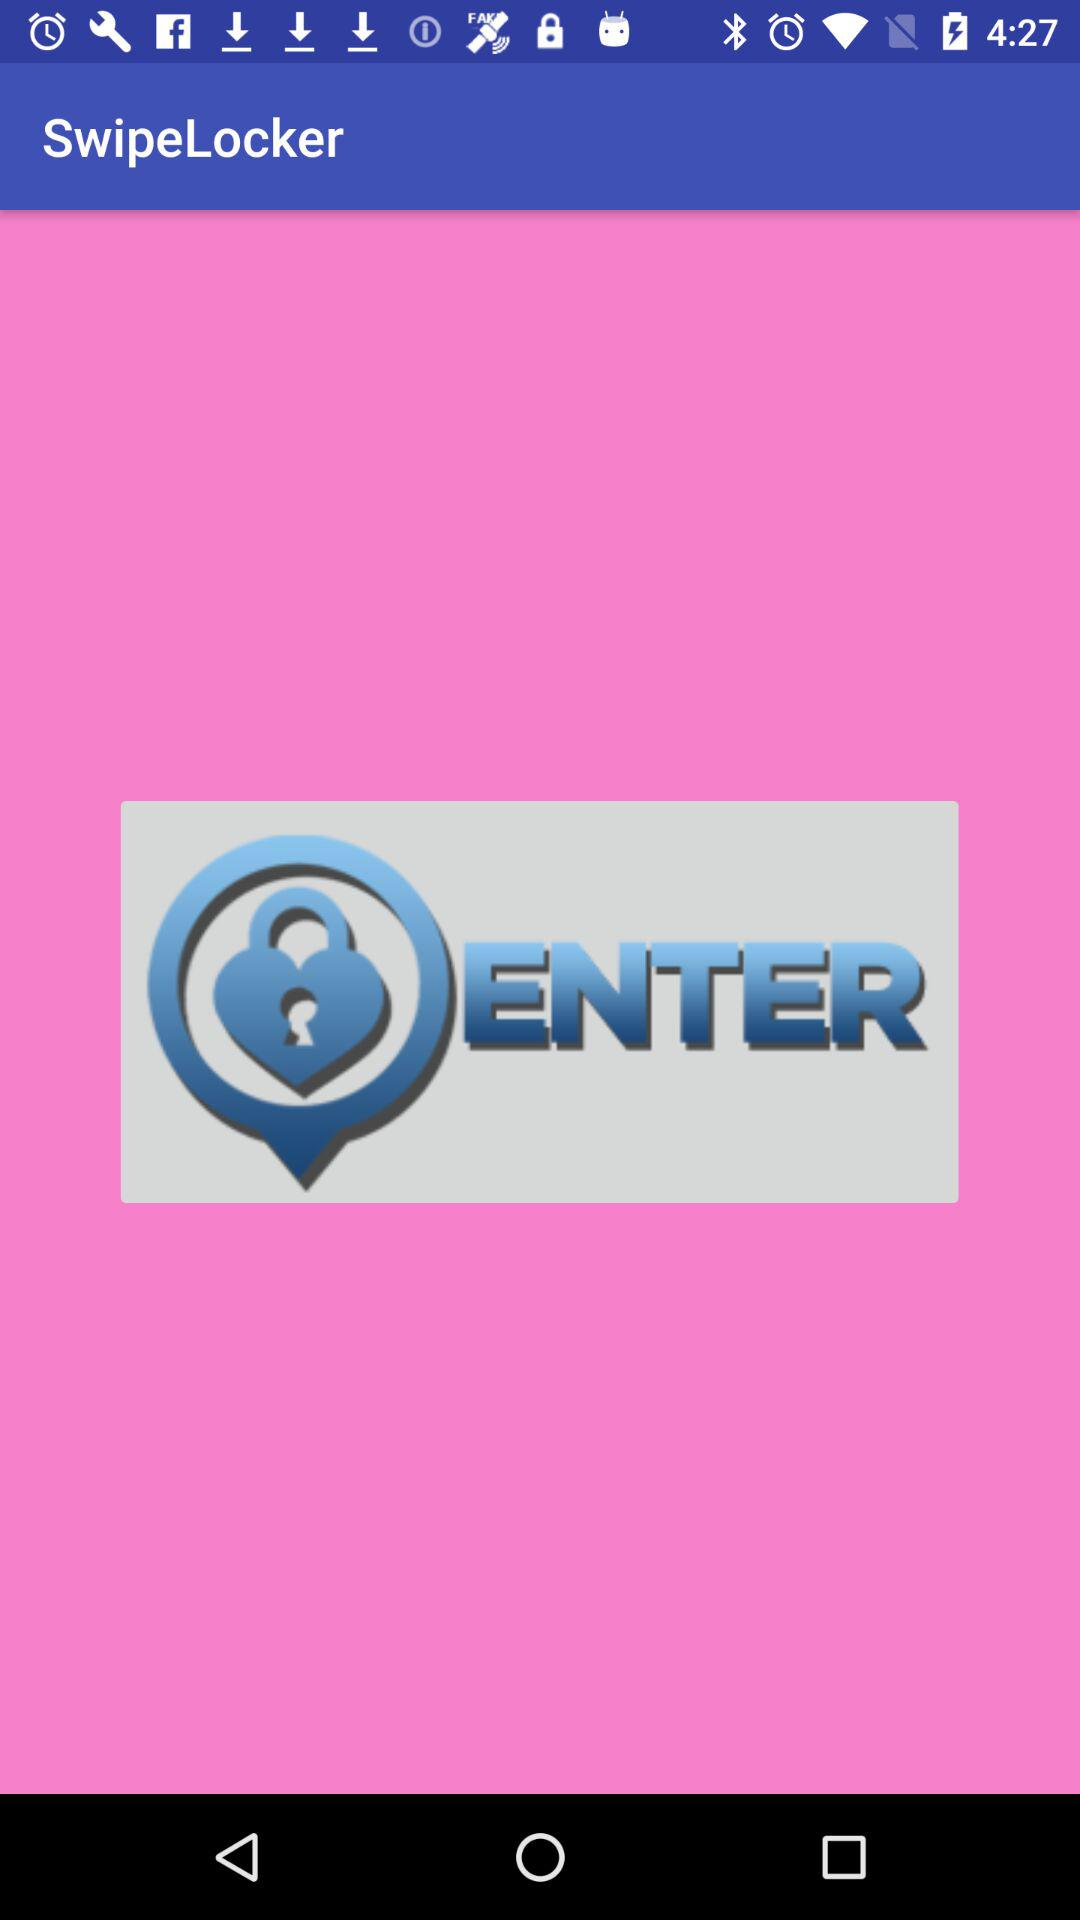What is the name of the application? The name of the application is "SwipeLocker". 